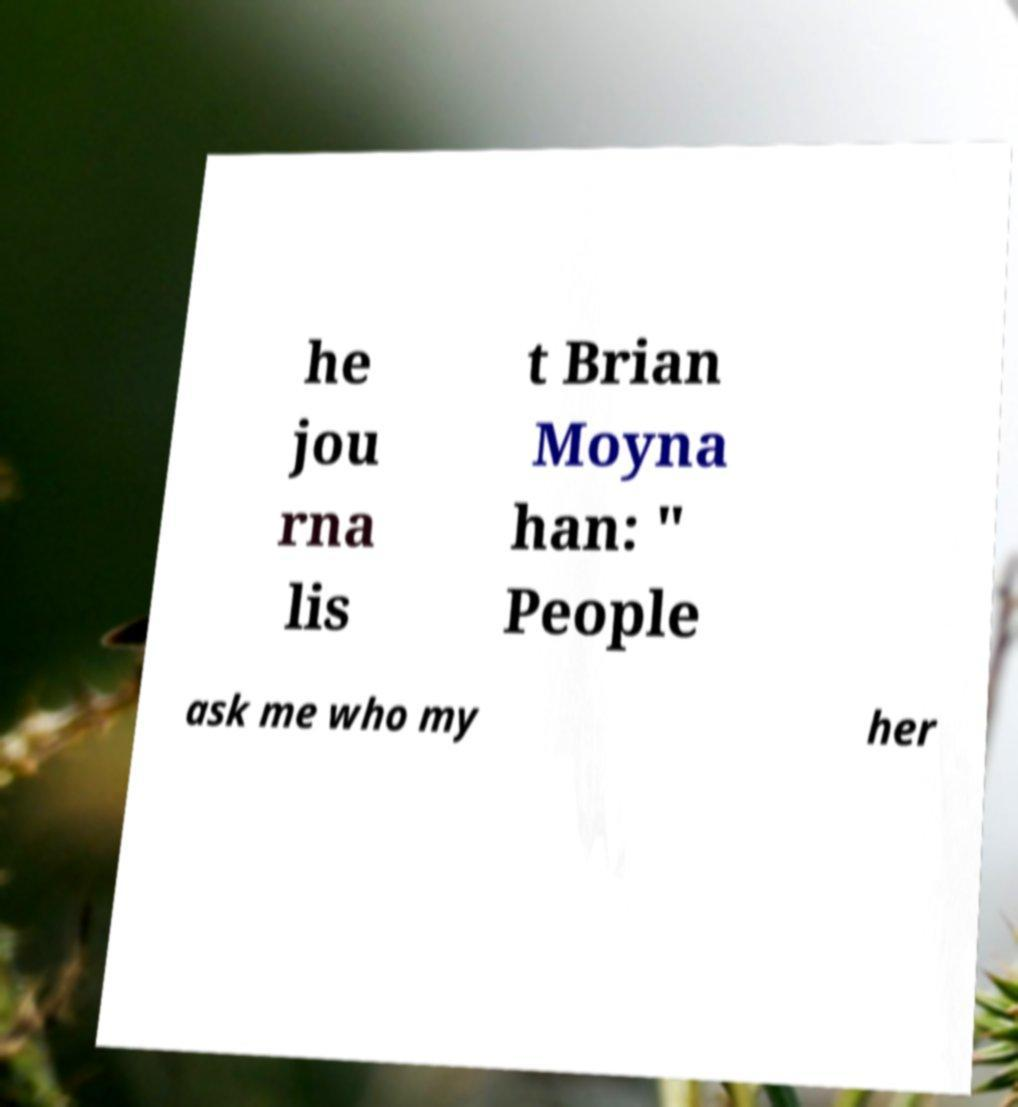Can you read and provide the text displayed in the image?This photo seems to have some interesting text. Can you extract and type it out for me? he jou rna lis t Brian Moyna han: " People ask me who my her 